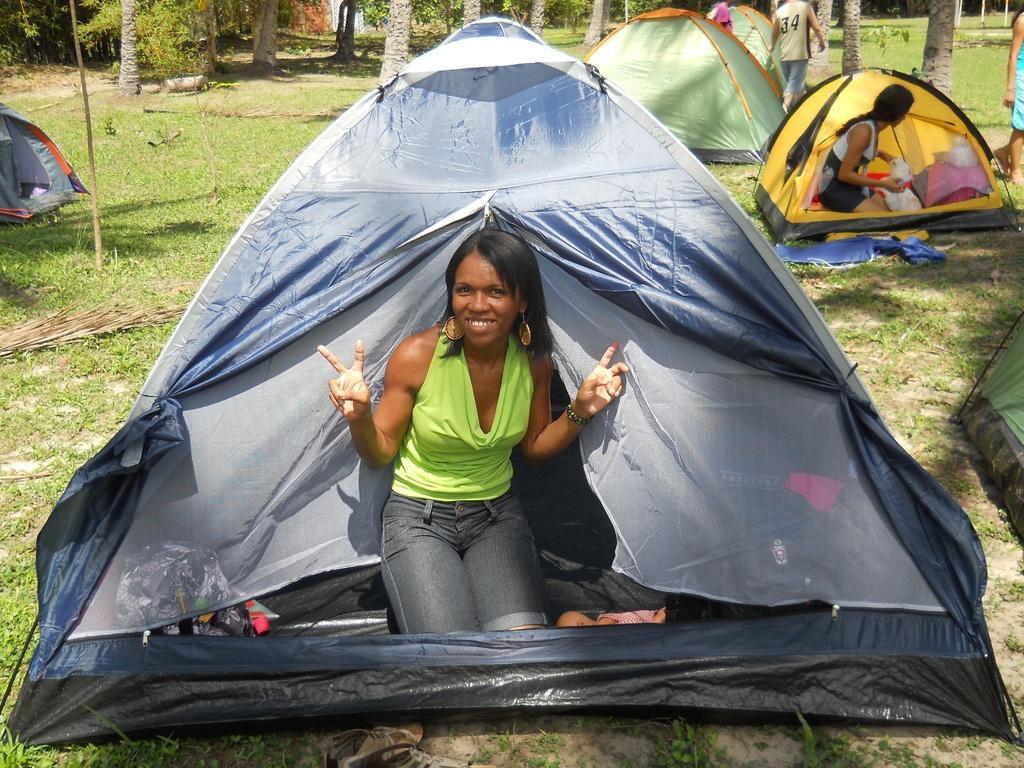Can you describe this image briefly? This image is taken outdoors. At the bottom of the image there is a ground with grass on it. In the middle of the image there is a woman in the tent. In the background there are many trees and plants and there are a few tents. On the right side of the image a woman is standing on the ground and another woman is in the tent and a man is walking on the ground. 